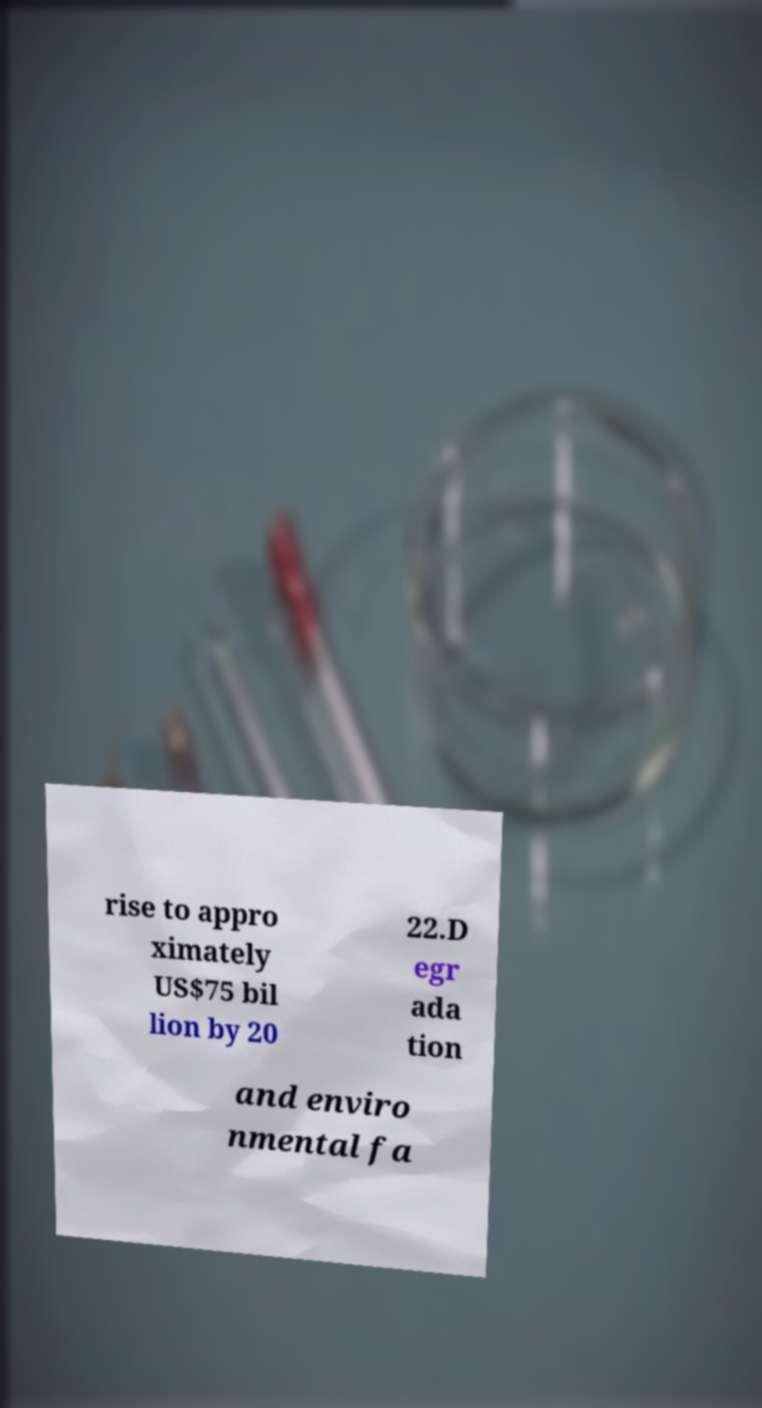There's text embedded in this image that I need extracted. Can you transcribe it verbatim? rise to appro ximately US$75 bil lion by 20 22.D egr ada tion and enviro nmental fa 